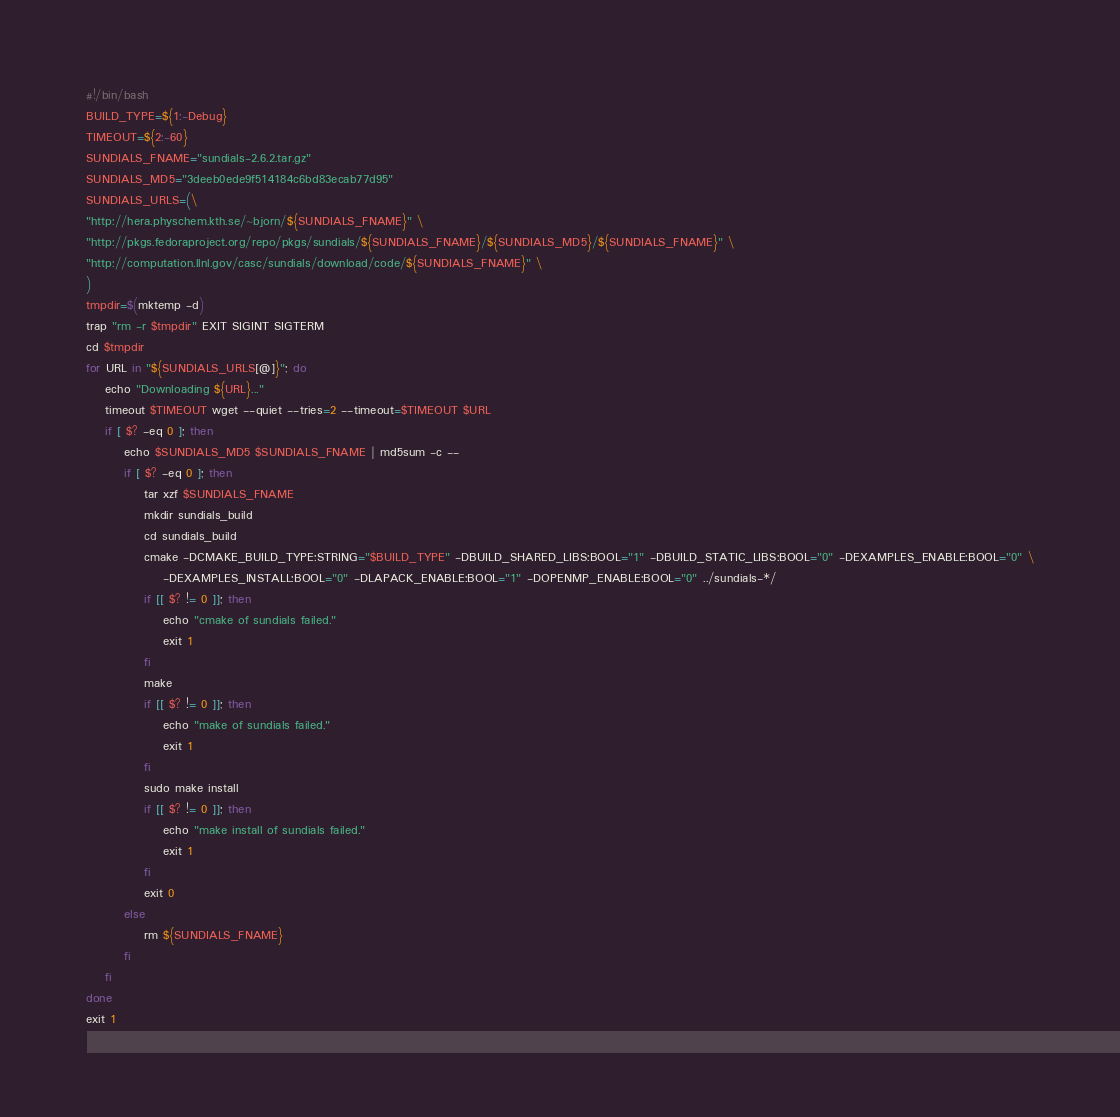Convert code to text. <code><loc_0><loc_0><loc_500><loc_500><_Bash_>#!/bin/bash
BUILD_TYPE=${1:-Debug}
TIMEOUT=${2:-60}
SUNDIALS_FNAME="sundials-2.6.2.tar.gz"
SUNDIALS_MD5="3deeb0ede9f514184c6bd83ecab77d95"
SUNDIALS_URLS=(\
"http://hera.physchem.kth.se/~bjorn/${SUNDIALS_FNAME}" \
"http://pkgs.fedoraproject.org/repo/pkgs/sundials/${SUNDIALS_FNAME}/${SUNDIALS_MD5}/${SUNDIALS_FNAME}" \
"http://computation.llnl.gov/casc/sundials/download/code/${SUNDIALS_FNAME}" \
)
tmpdir=$(mktemp -d)
trap "rm -r $tmpdir" EXIT SIGINT SIGTERM
cd $tmpdir
for URL in "${SUNDIALS_URLS[@]}"; do
    echo "Downloading ${URL}..."
    timeout $TIMEOUT wget --quiet --tries=2 --timeout=$TIMEOUT $URL
    if [ $? -eq 0 ]; then
        echo $SUNDIALS_MD5 $SUNDIALS_FNAME | md5sum -c --
        if [ $? -eq 0 ]; then
            tar xzf $SUNDIALS_FNAME
            mkdir sundials_build
            cd sundials_build
            cmake -DCMAKE_BUILD_TYPE:STRING="$BUILD_TYPE" -DBUILD_SHARED_LIBS:BOOL="1" -DBUILD_STATIC_LIBS:BOOL="0" -DEXAMPLES_ENABLE:BOOL="0" \
                -DEXAMPLES_INSTALL:BOOL="0" -DLAPACK_ENABLE:BOOL="1" -DOPENMP_ENABLE:BOOL="0" ../sundials-*/
            if [[ $? != 0 ]]; then
                echo "cmake of sundials failed."
                exit 1
            fi
            make
            if [[ $? != 0 ]]; then
                echo "make of sundials failed."
                exit 1
            fi
            sudo make install
            if [[ $? != 0 ]]; then
                echo "make install of sundials failed."
                exit 1
            fi
            exit 0
        else
            rm ${SUNDIALS_FNAME}
        fi
    fi    
done
exit 1
</code> 